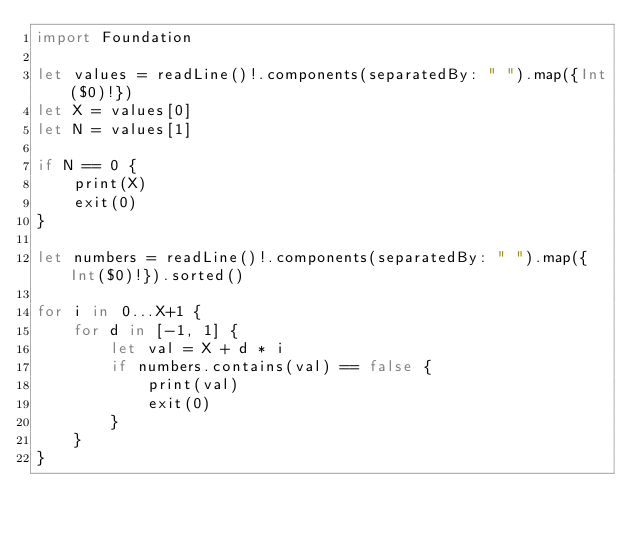Convert code to text. <code><loc_0><loc_0><loc_500><loc_500><_Swift_>import Foundation

let values = readLine()!.components(separatedBy: " ").map({Int($0)!})
let X = values[0]
let N = values[1]

if N == 0 {
    print(X)
    exit(0)
}

let numbers = readLine()!.components(separatedBy: " ").map({Int($0)!}).sorted()

for i in 0...X+1 {
    for d in [-1, 1] {
        let val = X + d * i
        if numbers.contains(val) == false {
            print(val)
            exit(0)
        }
    }
}

</code> 